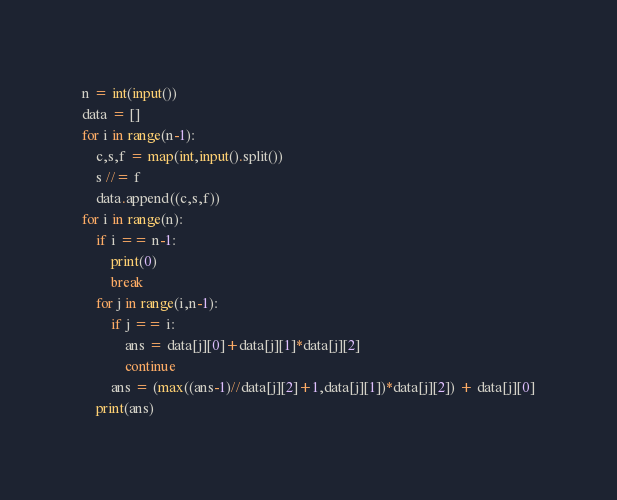<code> <loc_0><loc_0><loc_500><loc_500><_Python_>n = int(input())
data = []
for i in range(n-1):
    c,s,f = map(int,input().split())
    s //= f
    data.append((c,s,f))
for i in range(n):
    if i == n-1:
        print(0)
        break
    for j in range(i,n-1):
        if j == i:
            ans = data[j][0]+data[j][1]*data[j][2]
            continue
        ans = (max((ans-1)//data[j][2]+1,data[j][1])*data[j][2]) + data[j][0]
    print(ans)</code> 